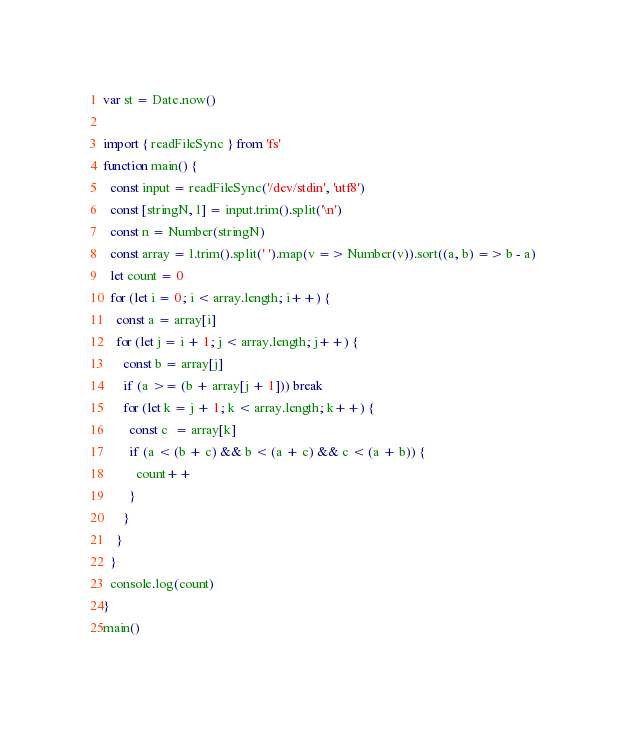Convert code to text. <code><loc_0><loc_0><loc_500><loc_500><_TypeScript_>var st = Date.now()

import { readFileSync } from 'fs'
function main() {
  const input = readFileSync('/dev/stdin', 'utf8')
  const [stringN, l] = input.trim().split('\n')
  const n = Number(stringN)
  const array = l.trim().split(' ').map(v => Number(v)).sort((a, b) => b - a)
  let count = 0
  for (let i = 0; i < array.length; i++) {
    const a = array[i]
    for (let j = i + 1; j < array.length; j++) {
      const b = array[j]
      if (a >= (b + array[j + 1])) break
      for (let k = j + 1; k < array.length; k++) {
        const c  = array[k]
        if (a < (b + c) && b < (a + c) && c < (a + b)) {
          count++
        }
      }
    }
  }
  console.log(count)
}
main()</code> 